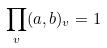Convert formula to latex. <formula><loc_0><loc_0><loc_500><loc_500>\prod _ { v } ( a , b ) _ { v } = 1</formula> 